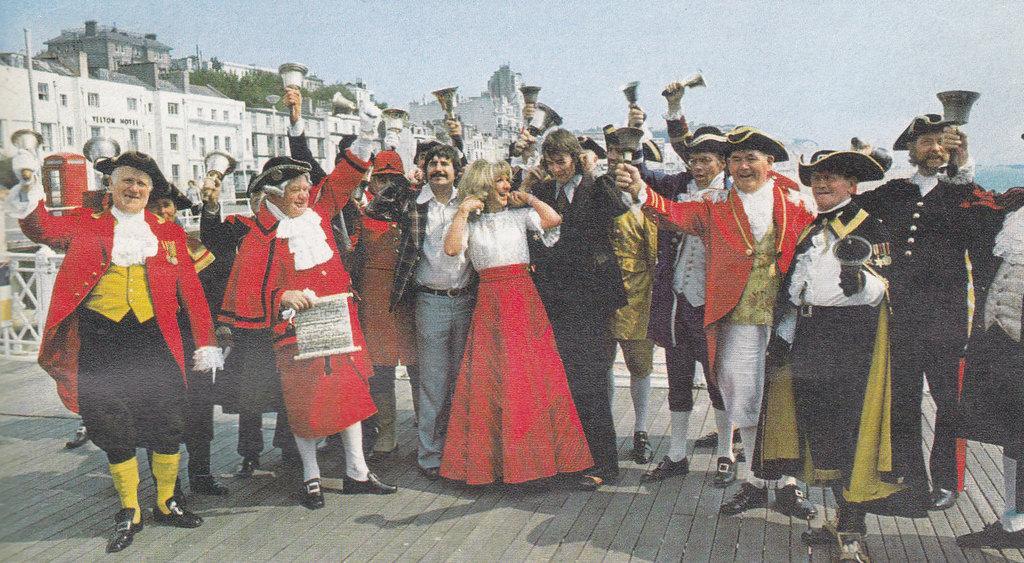How would you summarize this image in a sentence or two? In this picture group of people are standing and some wore black hat and everyone are giving some stills. In middle there is a women wore red skirt and white T-shirt and she smiles beautiful. Everyone are holding bell and wore gloves. The sky is in blue color. There are some trees, backside of this group of people there is a building which is in white color, in this building there is a window and there is fence over here. 